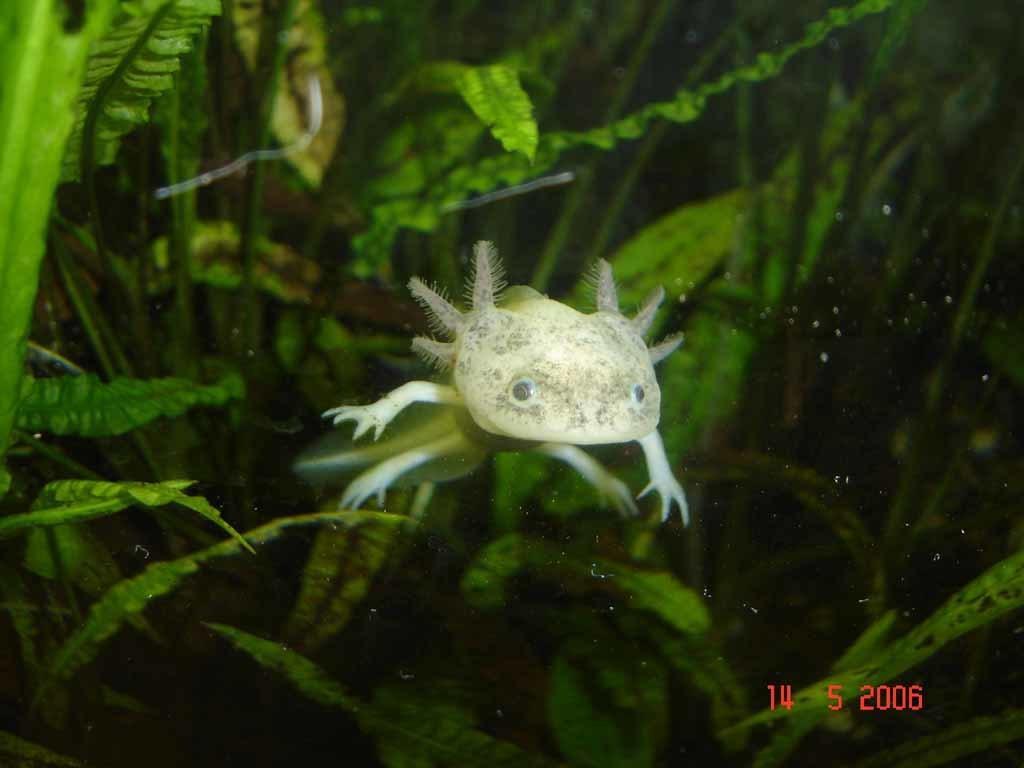Can you describe this image briefly? In this image I can see an animal. Background I can see plants in green color. 